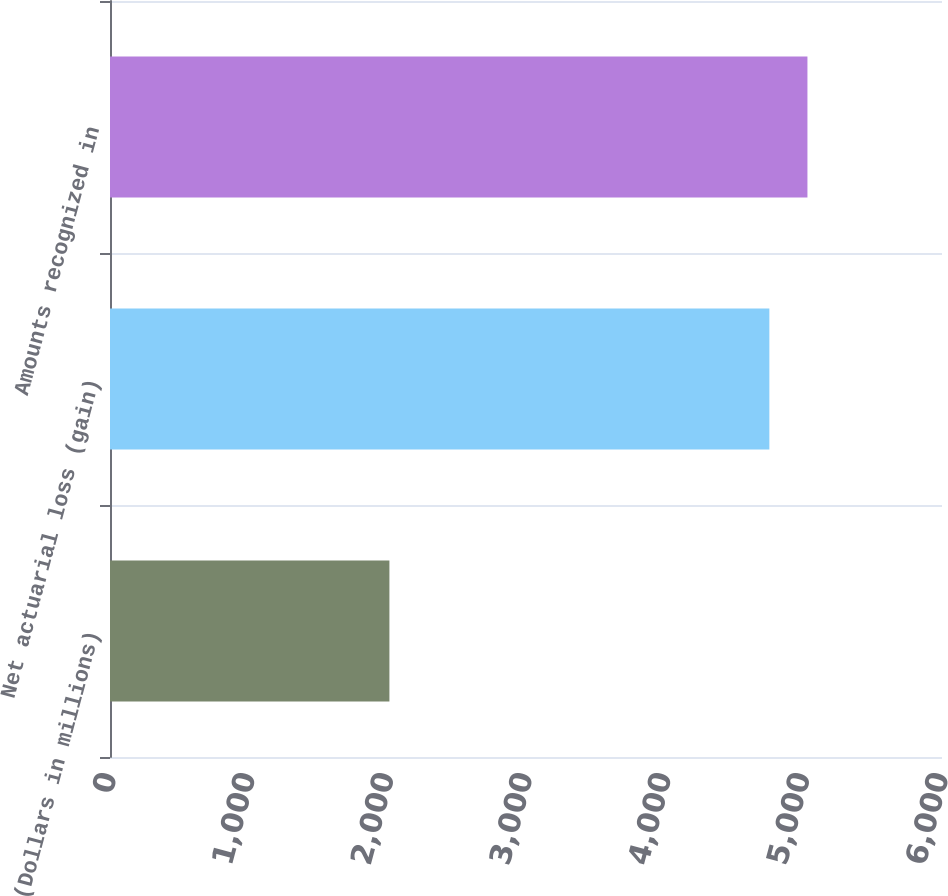Convert chart. <chart><loc_0><loc_0><loc_500><loc_500><bar_chart><fcel>(Dollars in millions)<fcel>Net actuarial loss (gain)<fcel>Amounts recognized in<nl><fcel>2015<fcel>4755<fcel>5029.6<nl></chart> 